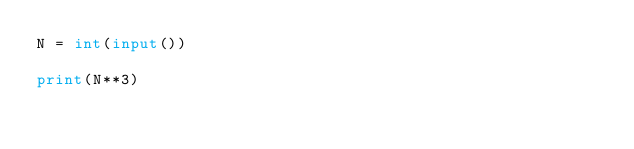<code> <loc_0><loc_0><loc_500><loc_500><_Python_>N = int(input())

print(N**3)</code> 